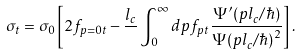<formula> <loc_0><loc_0><loc_500><loc_500>\sigma _ { t } = \sigma _ { 0 } \left [ 2 f _ { p = 0 t } - \frac { l _ { c } } { } \int _ { 0 } ^ { \infty } d p f _ { p t } \frac { \Psi ^ { \prime } ( p l _ { c } / \hbar { ) } } { \Psi ( p l _ { c } / \hbar { ) } ^ { 2 } } \right ] .</formula> 